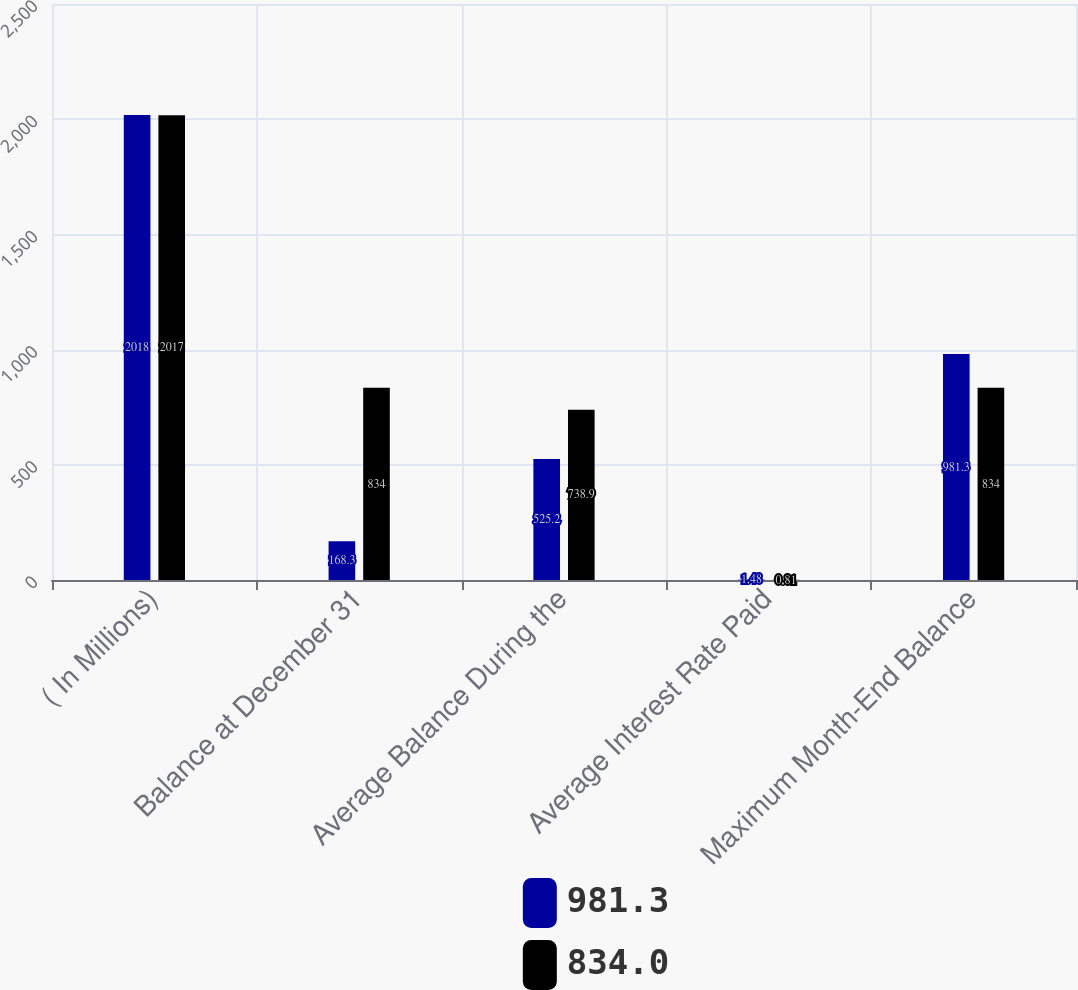<chart> <loc_0><loc_0><loc_500><loc_500><stacked_bar_chart><ecel><fcel>( In Millions)<fcel>Balance at December 31<fcel>Average Balance During the<fcel>Average Interest Rate Paid<fcel>Maximum Month-End Balance<nl><fcel>981.3<fcel>2018<fcel>168.3<fcel>525.2<fcel>1.48<fcel>981.3<nl><fcel>834<fcel>2017<fcel>834<fcel>738.9<fcel>0.81<fcel>834<nl></chart> 